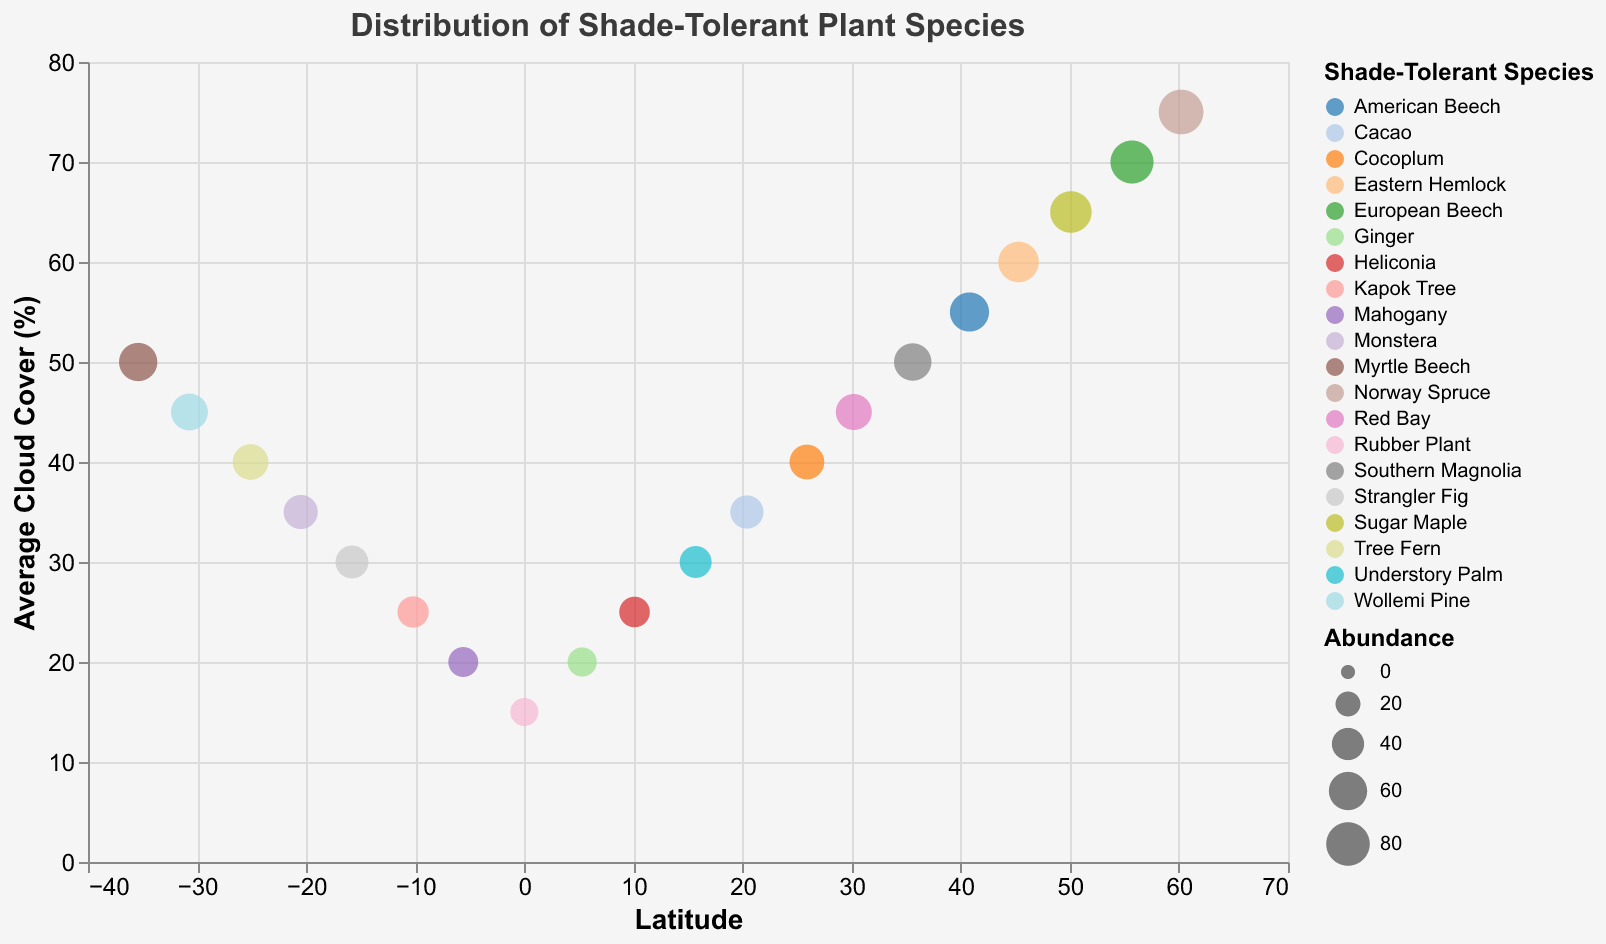What is the title of the figure? The title is located at the top of the figure in the center. It is specified in the title property of the plot.
Answer: Distribution of Shade-Tolerant Plant Species Which species have the lowest and highest abundances? To find this, look at the size of the circles representing abundance across the plot. The smallest and largest circles correspond to the lowest and highest abundances, respectively.
Answer: The Rubber Plant has the lowest (28) and the Norway Spruce has the highest (85) What is the average cloud cover at the latitude of 25.9? Locate the data point where Latitude is 25.9 on the horizontal axis and refer to its position on the vertical axis for Average Cloud Cover.
Answer: 40% How does the abundance of Mahogany compare to Ginger at similar cloud cover levels? Locate both data points for Mahogany and Ginger with approximately the same average cloud cover (20%), and compare the sizes of their circles.
Answer: Mahogany has a higher abundance (33) than Ginger (31) Do higher latitude areas generally correspond to higher average cloud cover? Identify data points with higher latitude values, and observe the corresponding average cloud cover values. Higher latitude points are expected to have higher values on the vertical axis if the correlation exists.
Answer: Yes, higher latitude areas generally correspond to higher average cloud cover What is the average abundance of species found in latitudes north of the equator? Identify species with Latitude values greater than 0 and calculate their average abundance. Sum their abundances and divide by the number of these species.
Answer: The sum of abundances is 93 + 78 + 72 + 68 + 63 + 57 + 52 + 48 + 43 + 39 + 35 + 31 + 28 = 681. There are 13 species, so the average is 681/13 ≈ 52.38 Which species is found at the highest latitude? Look for the data point with the highest value on the latitude axis and refer to the corresponding species.
Answer: Norway Spruce What is the range of cloud cover for species found between latitudes 10 and -10? Identify data points with Latitude values within this range and observe their corresponding cloud cover values to find the minimum and maximum.
Answer: The cloud cover ranges from 15 to 25% Between which latitudes does the Southern Magnolia species appear on the plot? Locate the data point for Southern Magnolia and note its latitude value on the x-axis.
Answer: 35.6 How does the abundance of species correlate with latitude within the data range provided? Examine the sizes of the circles along the latitude axis to deduce if there is a visible trend. Generally larger circles at particular latitudes indicate higher abundances.
Answer: Species at higher latitudes appear to have higher abundances 